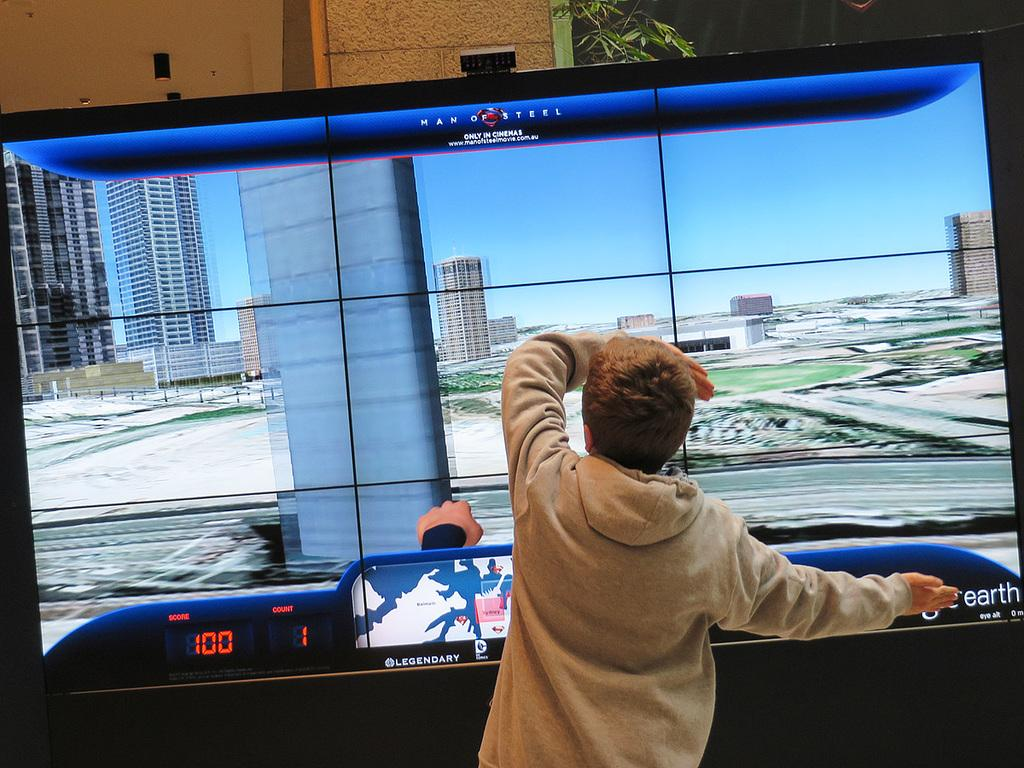Who is in the image? There is a boy in the image. What is the boy doing in the image? The boy is standing near a video game screen and touching the screen. What can be seen behind the screen? There is a pillar visible behind the screen. Are there any plants in the image? Yes, there is a small plant near the pillar. Can you see the boy kicking a ball in the yard in the image? No, there is no yard or ball visible in the image, and the boy is not kicking anything. 